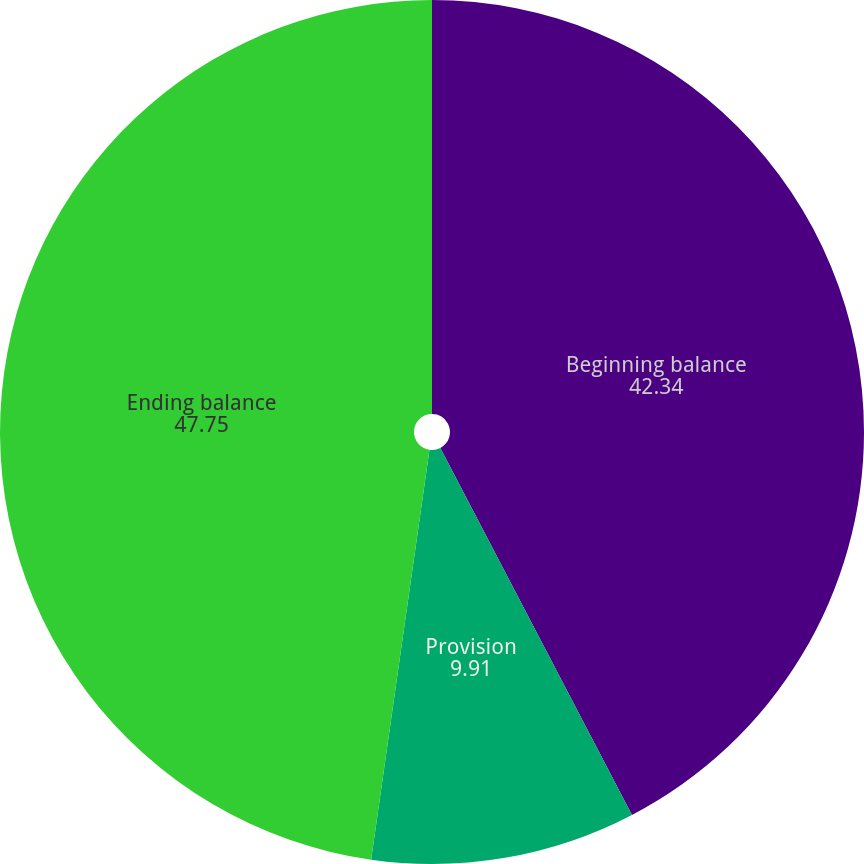<chart> <loc_0><loc_0><loc_500><loc_500><pie_chart><fcel>Beginning balance<fcel>Provision<fcel>Ending balance<nl><fcel>42.34%<fcel>9.91%<fcel>47.75%<nl></chart> 